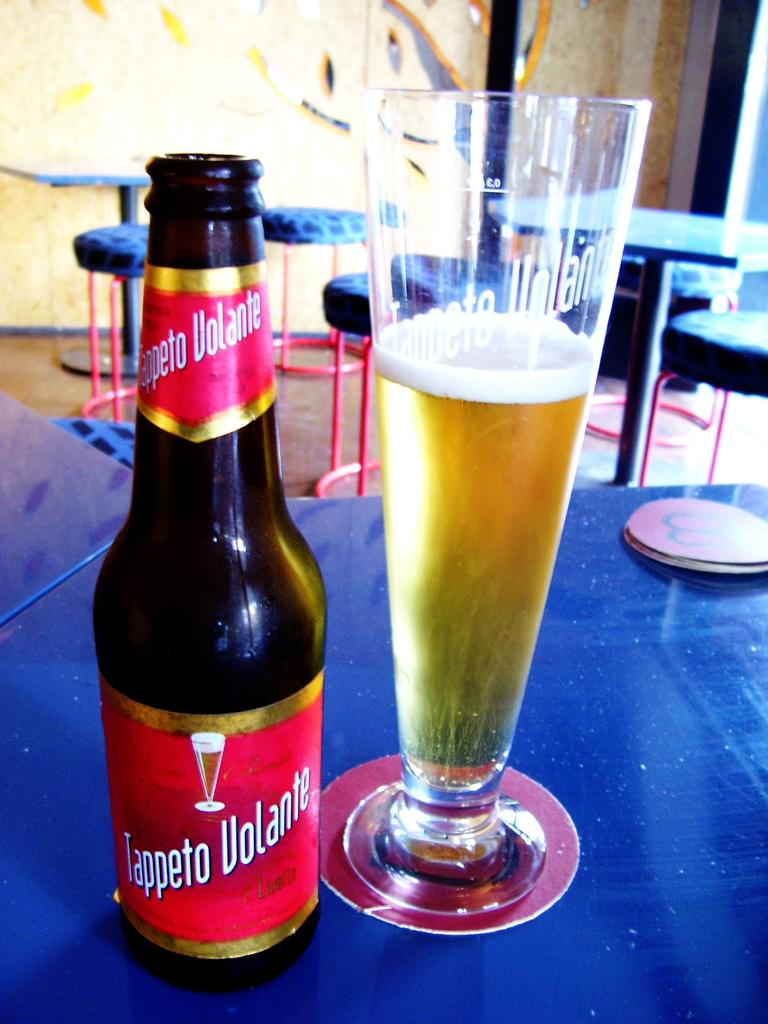<image>
Create a compact narrative representing the image presented. A bottle of Tappeto Volante beer next to a glass of beer. 